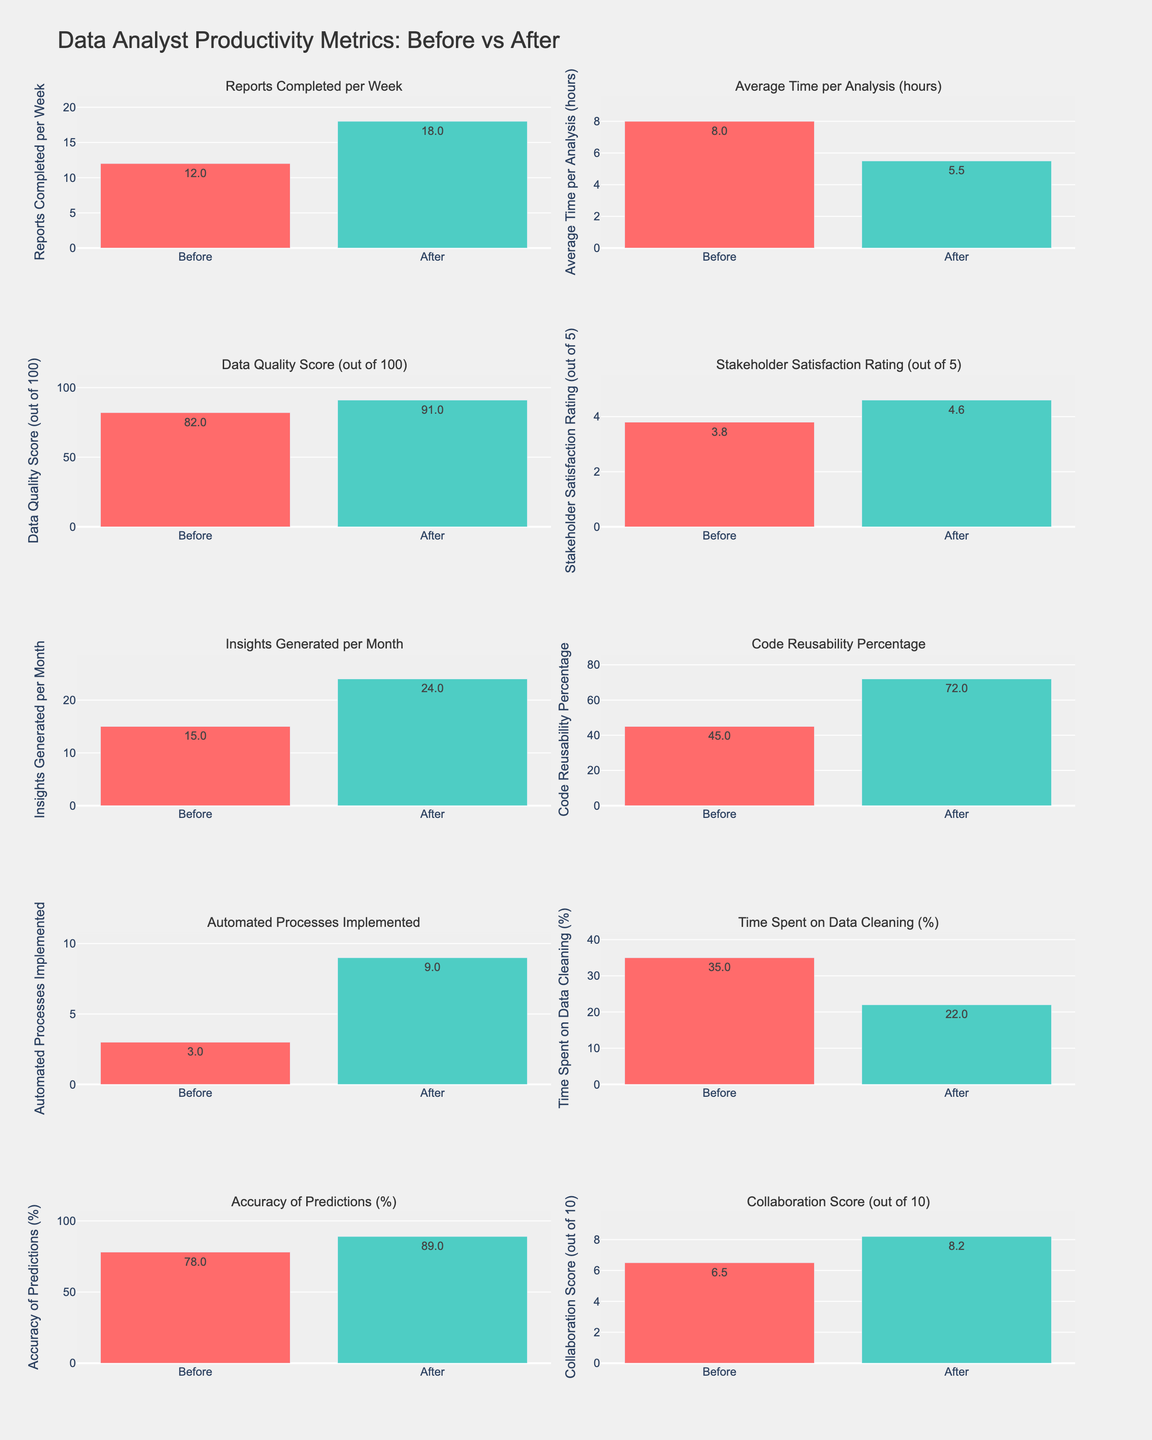What is the title of the subplot containing `Reports Completed per Week`? The subplot titles are labeled according to each metric, and the first subplot on the top left is labeled `Reports Completed per Week`
Answer: Reports Completed per Week How many subplots are there in total? The figure is created with subplots arranged in a 5x2 grid, indicating that there are 10 subplots in total.
Answer: 10 By how much did the `Average Time per Analysis` improve after introducing new analysis tools? We subtract the `After` value from the `Before` value: 8 - 5.5 = 2.5 hours
Answer: 2.5 hours Which metric showed the highest improvement in absolute number after the new tools were implemented? `Automated Processes Implemented` went from 3 to 9, which is an increase of 6 (9 - 3). This is the highest increase among all metrics displayed in the subplots.
Answer: Automated Processes Implemented What's the combined `Data Quality Score` before and after implementing new tools? We sum the `Before` and `After` values: 82 + 91 = 173
Answer: 173 Which metric has the smallest relative change compared to its `Before` value? To calculate the relative change, find the difference between `Before` and `After` values for each metric, divide by the `Before` value, and identify the smallest result. For `Stakeholder Satisfaction Rating`, the increase is from 3.8 to 4.6, which is a relative change of (4.6 - 3.8) / 3.8 ≈ 0.21, or 21%. This is the smallest relative change among all metrics listed.
Answer: Stakeholder Satisfaction Rating Which metric saw an increase in its percentage value by more than 25 percentage points? `Code Reusability Percentage` increased from 45% to 72%, which is an increase of 27 percentage points (72 - 45).
Answer: Code Reusability Percentage Did the `Collaboration Score` improve to a value greater than 7 after implementing the new analysis tools? The `Collaboration Score` improved from 6.5 to 8.2. Since 8.2 is greater than 7, the score did indeed improve to a value greater than 7.
Answer: Yes Which metric had a higher `After` score than `Before` score by approximately 10 or more? `Accuracy of Predictions` improved from 78% to 89%, which is a difference of 11 percentage points (89 - 78).
Answer: Accuracy of Predictions How much time was saved on data cleaning activities in percentage terms after using the new tools? The percentage of time spent on data cleaning went from 35% to 22%. The time saved is 35% - 22% = 13 percentage points
Answer: 13 percentage points 